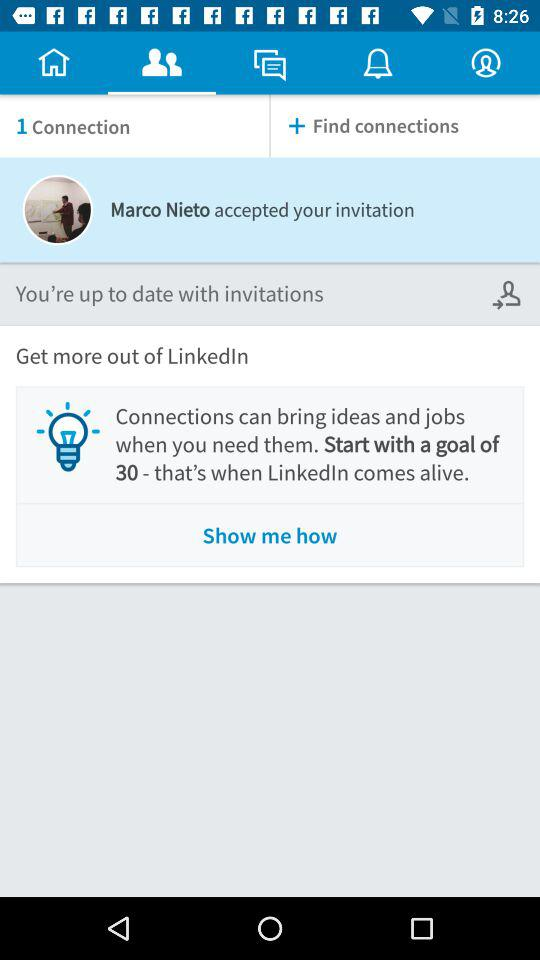How many connections do I have?
Answer the question using a single word or phrase. 1 